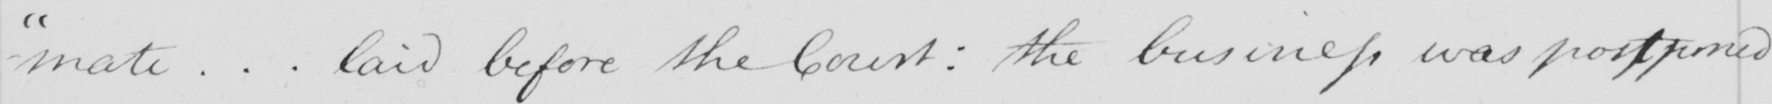Transcribe the text shown in this historical manuscript line. - " mate .. . laid before the Court :  the business was postponed 